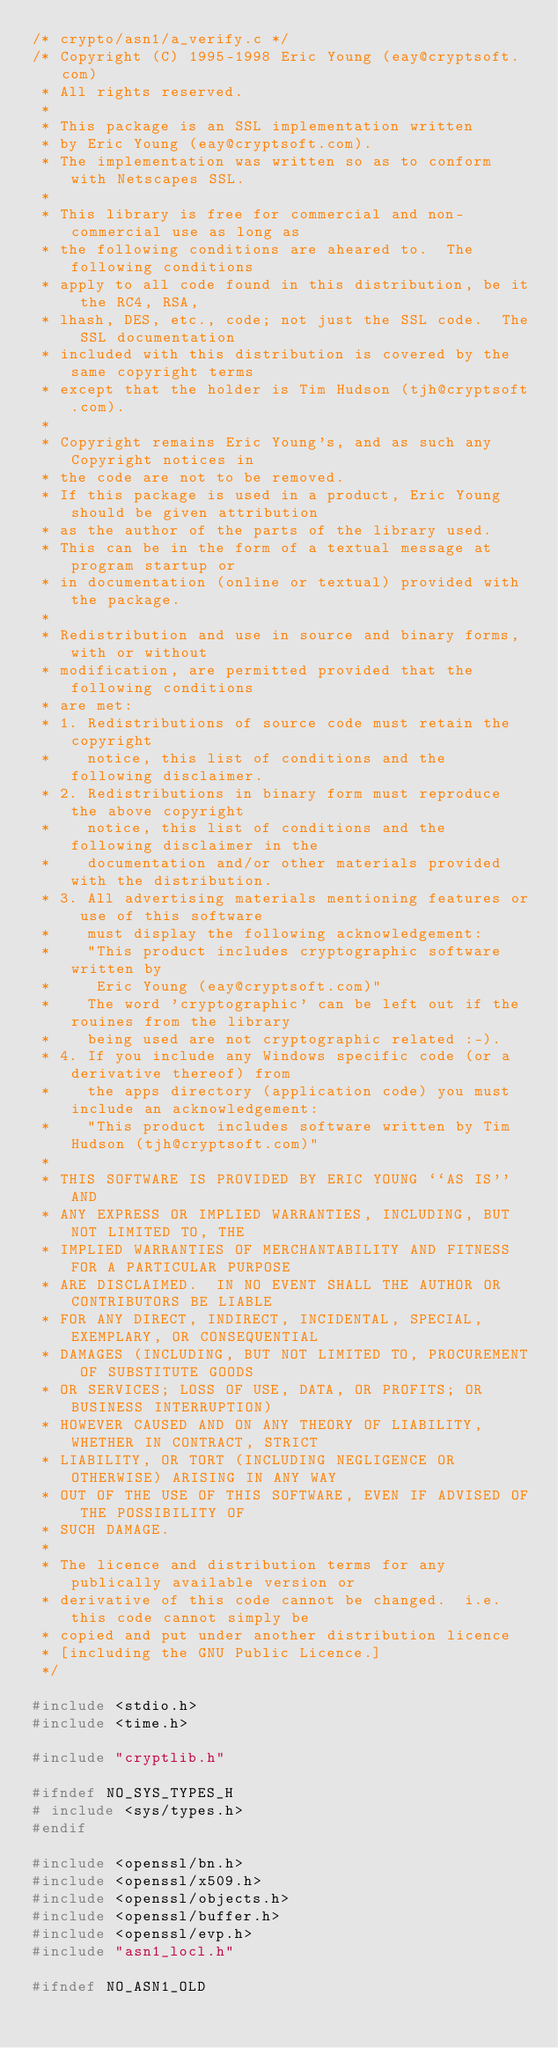Convert code to text. <code><loc_0><loc_0><loc_500><loc_500><_C_>/* crypto/asn1/a_verify.c */
/* Copyright (C) 1995-1998 Eric Young (eay@cryptsoft.com)
 * All rights reserved.
 *
 * This package is an SSL implementation written
 * by Eric Young (eay@cryptsoft.com).
 * The implementation was written so as to conform with Netscapes SSL.
 * 
 * This library is free for commercial and non-commercial use as long as
 * the following conditions are aheared to.  The following conditions
 * apply to all code found in this distribution, be it the RC4, RSA,
 * lhash, DES, etc., code; not just the SSL code.  The SSL documentation
 * included with this distribution is covered by the same copyright terms
 * except that the holder is Tim Hudson (tjh@cryptsoft.com).
 * 
 * Copyright remains Eric Young's, and as such any Copyright notices in
 * the code are not to be removed.
 * If this package is used in a product, Eric Young should be given attribution
 * as the author of the parts of the library used.
 * This can be in the form of a textual message at program startup or
 * in documentation (online or textual) provided with the package.
 * 
 * Redistribution and use in source and binary forms, with or without
 * modification, are permitted provided that the following conditions
 * are met:
 * 1. Redistributions of source code must retain the copyright
 *    notice, this list of conditions and the following disclaimer.
 * 2. Redistributions in binary form must reproduce the above copyright
 *    notice, this list of conditions and the following disclaimer in the
 *    documentation and/or other materials provided with the distribution.
 * 3. All advertising materials mentioning features or use of this software
 *    must display the following acknowledgement:
 *    "This product includes cryptographic software written by
 *     Eric Young (eay@cryptsoft.com)"
 *    The word 'cryptographic' can be left out if the rouines from the library
 *    being used are not cryptographic related :-).
 * 4. If you include any Windows specific code (or a derivative thereof) from 
 *    the apps directory (application code) you must include an acknowledgement:
 *    "This product includes software written by Tim Hudson (tjh@cryptsoft.com)"
 * 
 * THIS SOFTWARE IS PROVIDED BY ERIC YOUNG ``AS IS'' AND
 * ANY EXPRESS OR IMPLIED WARRANTIES, INCLUDING, BUT NOT LIMITED TO, THE
 * IMPLIED WARRANTIES OF MERCHANTABILITY AND FITNESS FOR A PARTICULAR PURPOSE
 * ARE DISCLAIMED.  IN NO EVENT SHALL THE AUTHOR OR CONTRIBUTORS BE LIABLE
 * FOR ANY DIRECT, INDIRECT, INCIDENTAL, SPECIAL, EXEMPLARY, OR CONSEQUENTIAL
 * DAMAGES (INCLUDING, BUT NOT LIMITED TO, PROCUREMENT OF SUBSTITUTE GOODS
 * OR SERVICES; LOSS OF USE, DATA, OR PROFITS; OR BUSINESS INTERRUPTION)
 * HOWEVER CAUSED AND ON ANY THEORY OF LIABILITY, WHETHER IN CONTRACT, STRICT
 * LIABILITY, OR TORT (INCLUDING NEGLIGENCE OR OTHERWISE) ARISING IN ANY WAY
 * OUT OF THE USE OF THIS SOFTWARE, EVEN IF ADVISED OF THE POSSIBILITY OF
 * SUCH DAMAGE.
 * 
 * The licence and distribution terms for any publically available version or
 * derivative of this code cannot be changed.  i.e. this code cannot simply be
 * copied and put under another distribution licence
 * [including the GNU Public Licence.]
 */

#include <stdio.h>
#include <time.h>

#include "cryptlib.h"

#ifndef NO_SYS_TYPES_H
# include <sys/types.h>
#endif

#include <openssl/bn.h>
#include <openssl/x509.h>
#include <openssl/objects.h>
#include <openssl/buffer.h>
#include <openssl/evp.h>
#include "asn1_locl.h"

#ifndef NO_ASN1_OLD
</code> 